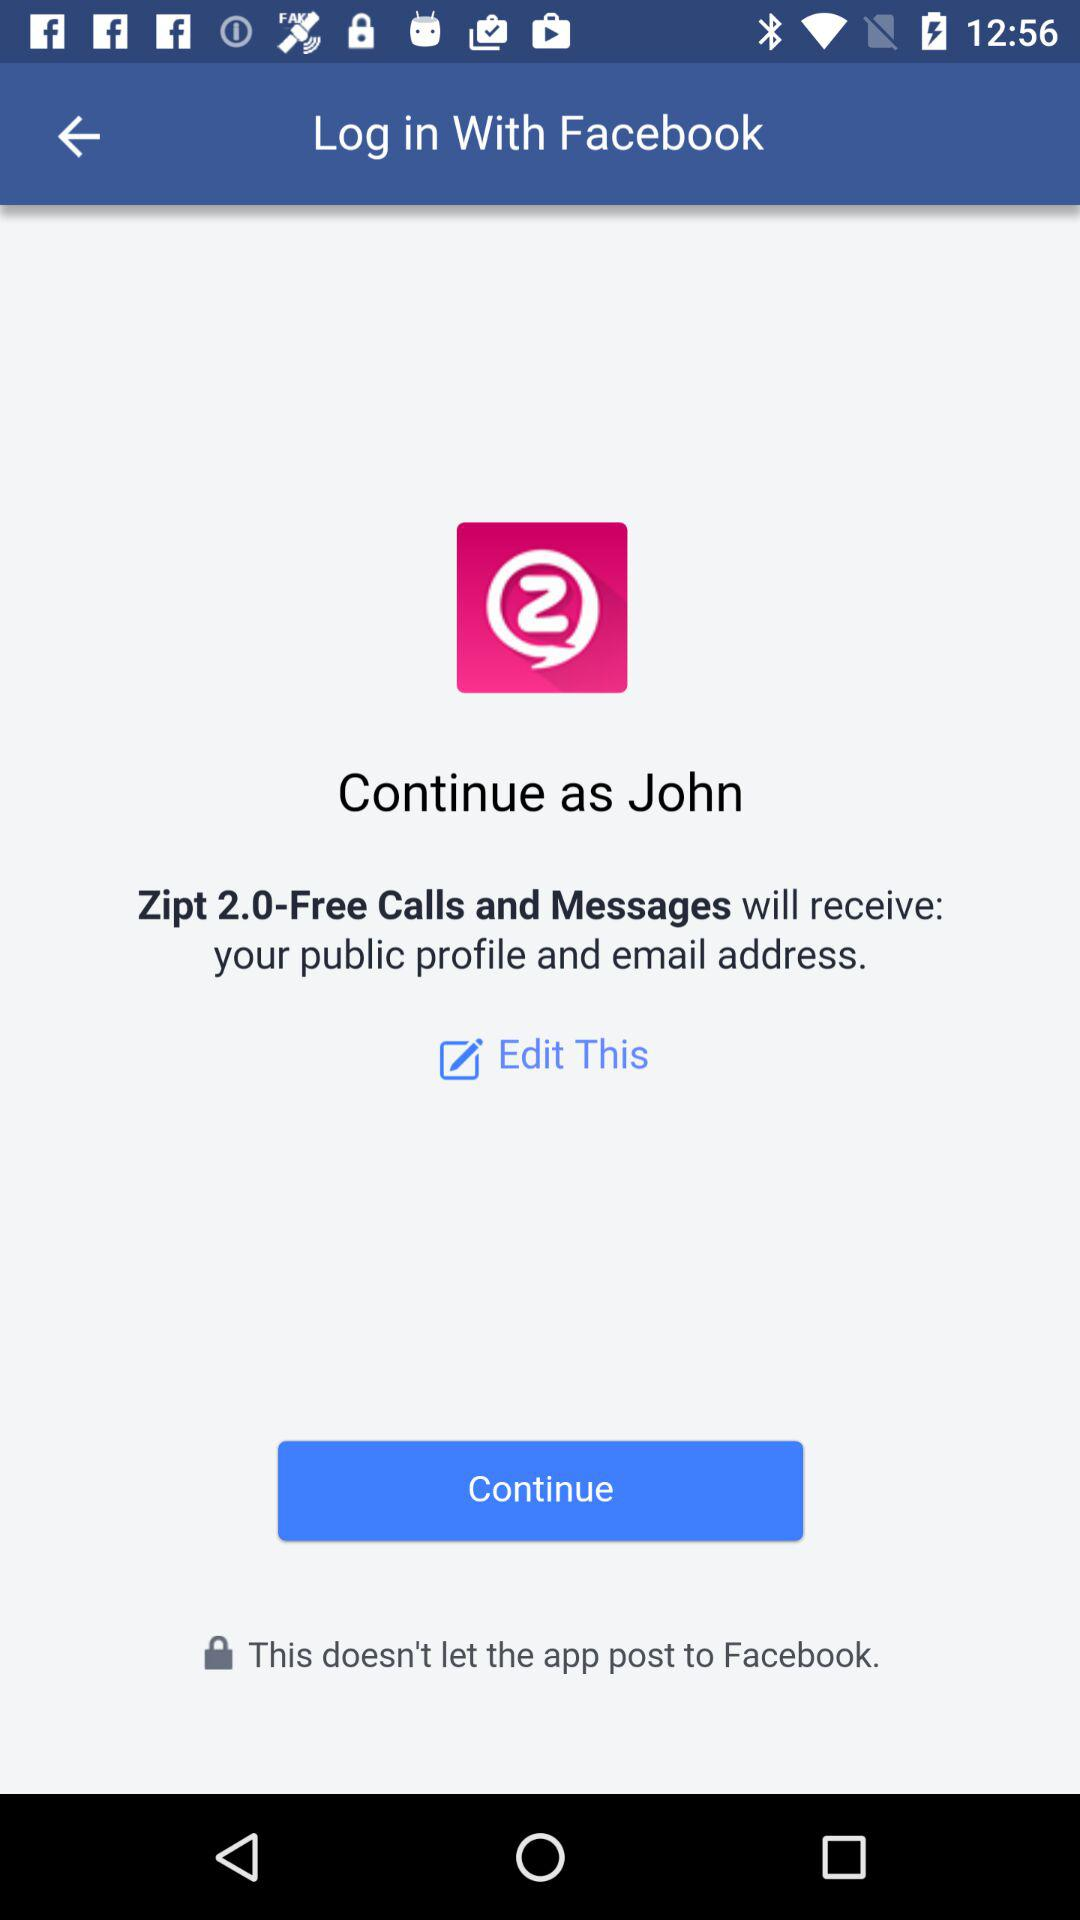What application is asking for permission? The application asking for permission is "Zipt 2.0-Free Calls and Messages". 